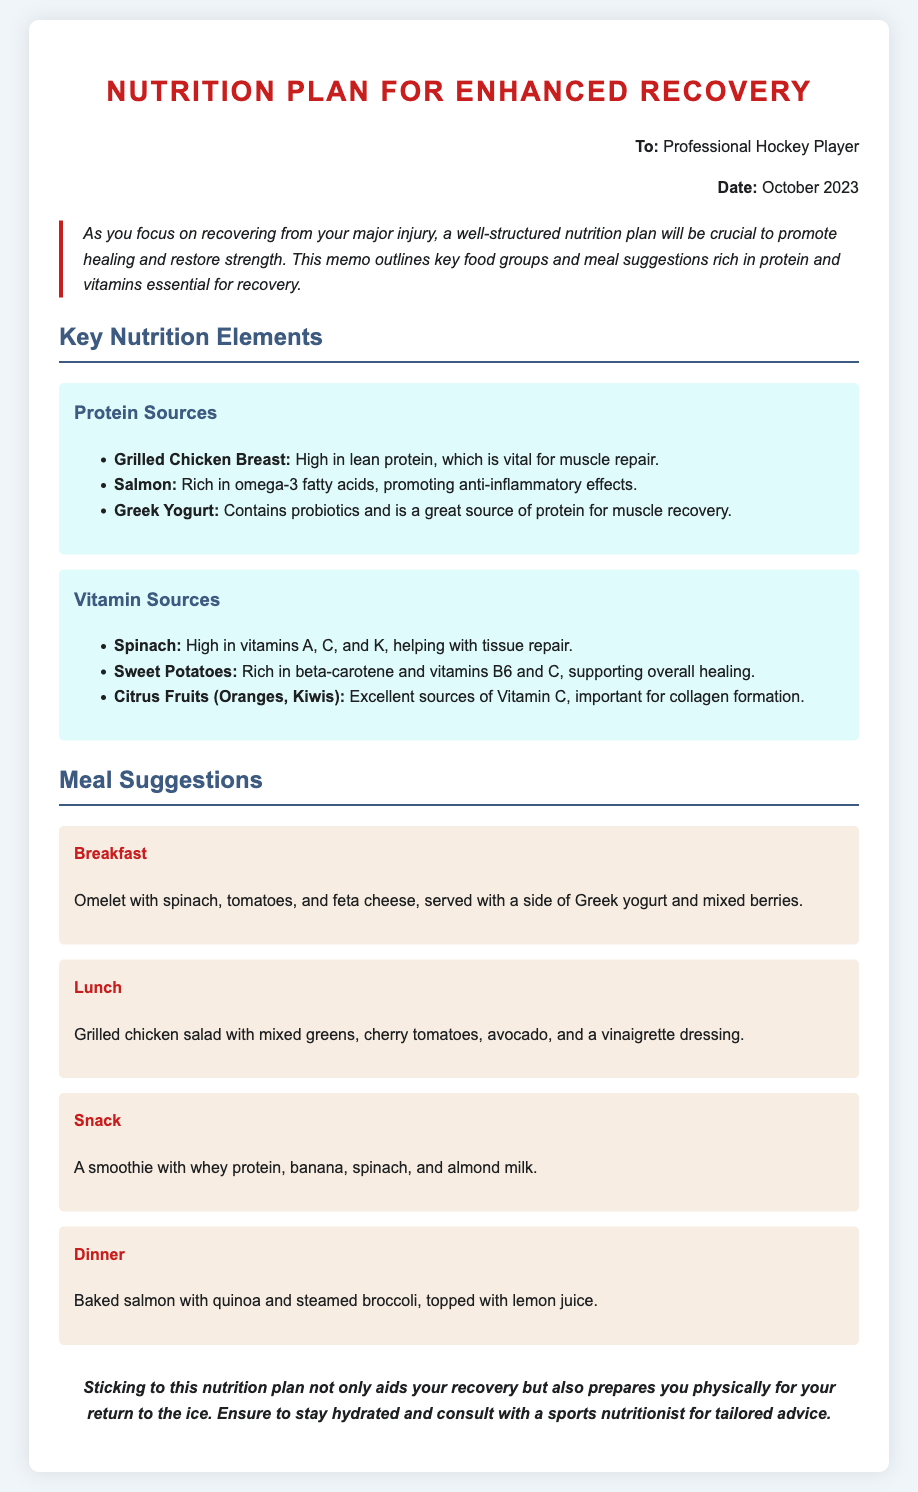What is the main purpose of the memo? The memo outlines a well-structured nutrition plan to promote healing and restore strength during recovery from injury.
Answer: Nutrition plan for enhanced recovery Who is the memo addressed to? The "To" section specifies the recipient of the memo, which is a professional hockey player.
Answer: Professional Hockey Player What is a suggested breakfast from the meal suggestions? The breakfast meal suggestion includes an omelet with spinach, tomatoes, and feta cheese, along with a side of Greek yogurt and mixed berries.
Answer: Omelet with spinach, tomatoes, and feta cheese, served with a side of Greek yogurt and mixed berries List one protein source mentioned in the document. The document provides several protein sources, one of which is grilled chicken breast.
Answer: Grilled Chicken Breast What benefit does omega-3 fatty acids provide according to the memo? The memo states that omega-3 fatty acids promote anti-inflammatory effects, which aids in recovery.
Answer: Anti-inflammatory effects How many key nutrition elements are mentioned in the memo? The document covers two main key nutrition elements: Protein Sources and Vitamin Sources.
Answer: Two What is one of the suggested dinner meals? The dinner suggestion provided in the memo is baked salmon with quinoa and steamed broccoli, topped with lemon juice.
Answer: Baked salmon with quinoa and steamed broccoli, topped with lemon juice What is emphasized about hydration in the memo? The closing remarks highlight the importance of staying hydrated during the recovery process.
Answer: Stay hydrated Which vitamins are highlighted in the Vitamin Sources section? The Vitamin Sources section mentions vitamins A, C, K, B6, and C again, emphasizing their role in healing.
Answer: Vitamins A, C, K, B6, and C 